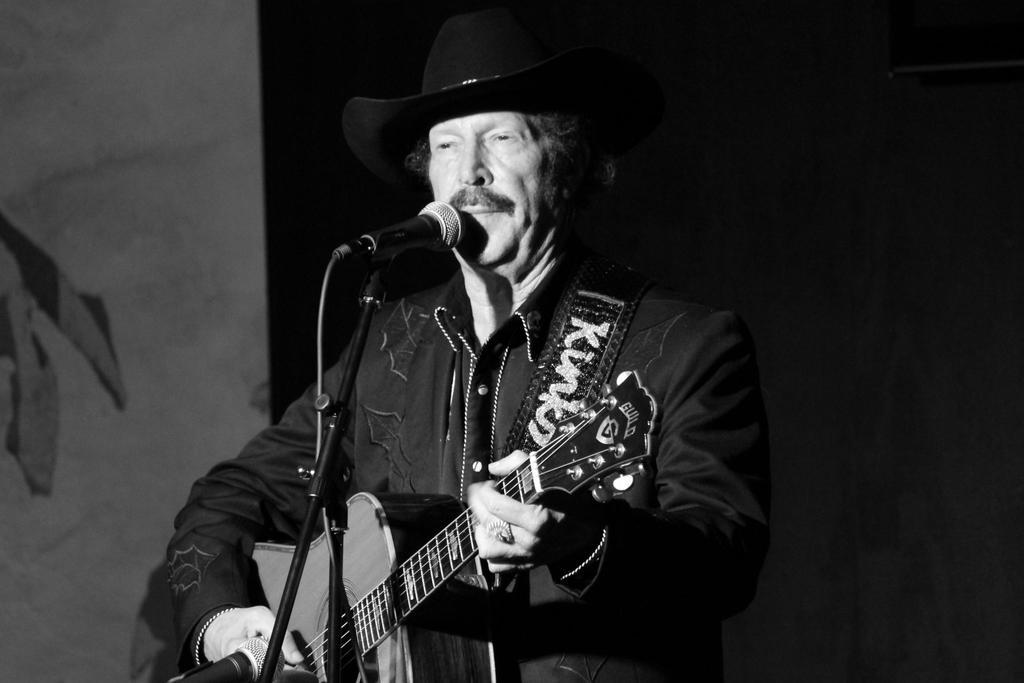What is the person in the image doing? The person is standing and playing a guitar. Can you describe the person's attire? The person is wearing a black color hat. What is in front of the person? There is a microphone with a stand in front of the person. What can be seen in the background of the image? There is a wall in the background. Where is the lawyer's nest located in the image? There is no lawyer or nest present in the image. 